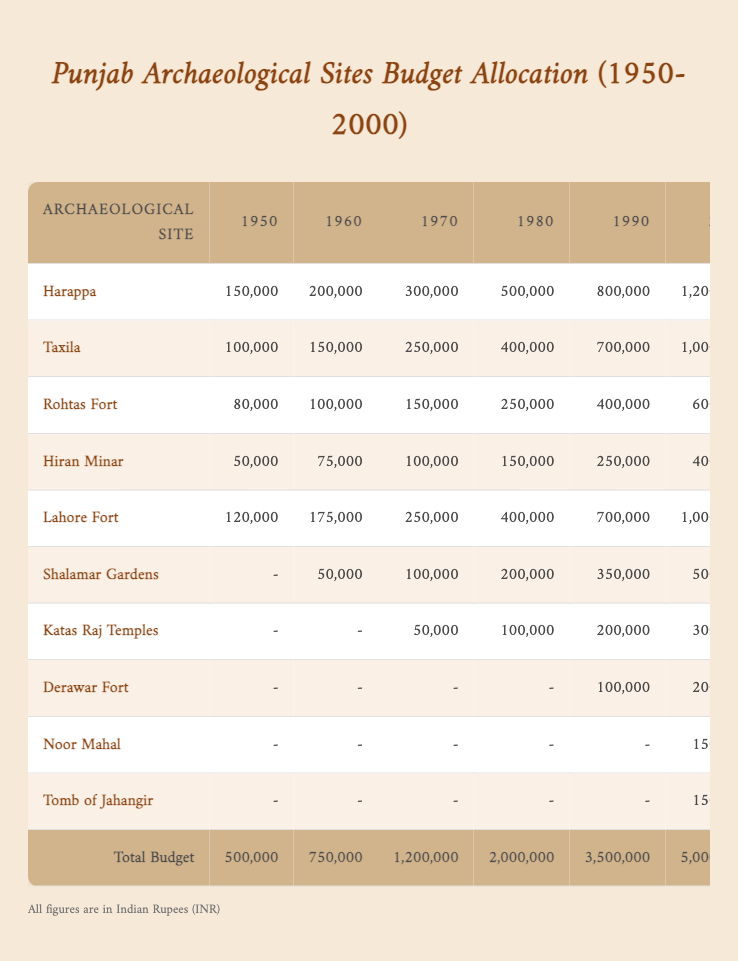What was the total budget allocated in 1980? The total budget for the year 1980 is explicitly stated in the last row of the table's 'Total Budget' column, which shows 2,000,000.
Answer: 2,000,000 Which site received the highest allocation in 1990? Looking at the 1990 column, the highest allocation is for Harappa, which is listed with 800,000.
Answer: Harappa What was the difference in budget allocation for Rohtas Fort between 1970 and 2000? To find the difference, subtract the 1970 allocation (150,000) from the 2000 allocation (600,000): 600,000 - 150,000 = 450,000.
Answer: 450,000 Did Shalamar Gardens receive any budget allocation in 1950? Based on the table, there is no budget allocation for Shalamar Gardens in 1950, as indicated by the dash next to the year 1950.
Answer: No What was the average budget allocation for Taxila from 1950 to 2000? To compute the average, first sum the allocations for Taxila from 1950 (100,000) to 2000 (1,000,000): 100,000 + 150,000 + 250,000 + 400,000 + 700,000 + 1,000,000 = 2,600,000. Then, divide by the number of years (6): 2,600,000 / 6 = 433,333.33.
Answer: 433,333.33 Which two sites had the same allocation in 1990, and what was that amount? Looking at the 1990 column, both Hiran Minar and Katas Raj Temples had the same allocation of 250,000.
Answer: 250,000 (both Hiran Minar and Katas Raj Temples) How much more money was allocated to Harappa in 2000 compared to 1950? To find this, subtract the 1950 allocation for Harappa (150,000) from the 2000 allocation (1,200,000): 1,200,000 - 150,000 = 1,050,000.
Answer: 1,050,000 Was there any budget allocation for the Tomb of Jahangir before 2000? According to the table, there is no allocation for the Tomb of Jahangir listed in the years prior to 2000, which is indicated by the dash for those years.
Answer: No In which decade did the overall budget allocation double compared to the previous decade? Comparing the total budgets, the allocation went from 1,200,000 in 1970 to 2,000,000 in 1980. Since 2,000,000 is not double 1,200,000, the next comparison is from 1980 to 1990, where it increased from 2,000,000 to 3,500,000, which is also not double. Lastly, from 1990 to 2000 the total budget increased from 3,500,000 to 5,000,000, which is an increase but does not technically double until analyzed with past data. Therefore, the decade after 1990 saw the largest increase.
Answer: From 1990 to 2000 